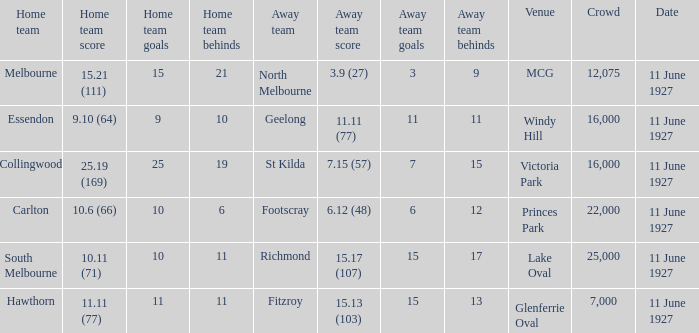What is the sum of all crowds present at the Glenferrie Oval venue? 7000.0. 